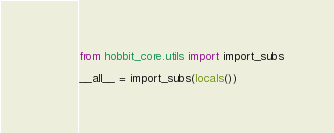<code> <loc_0><loc_0><loc_500><loc_500><_Python_>from hobbit_core.utils import import_subs

__all__ = import_subs(locals())
</code> 